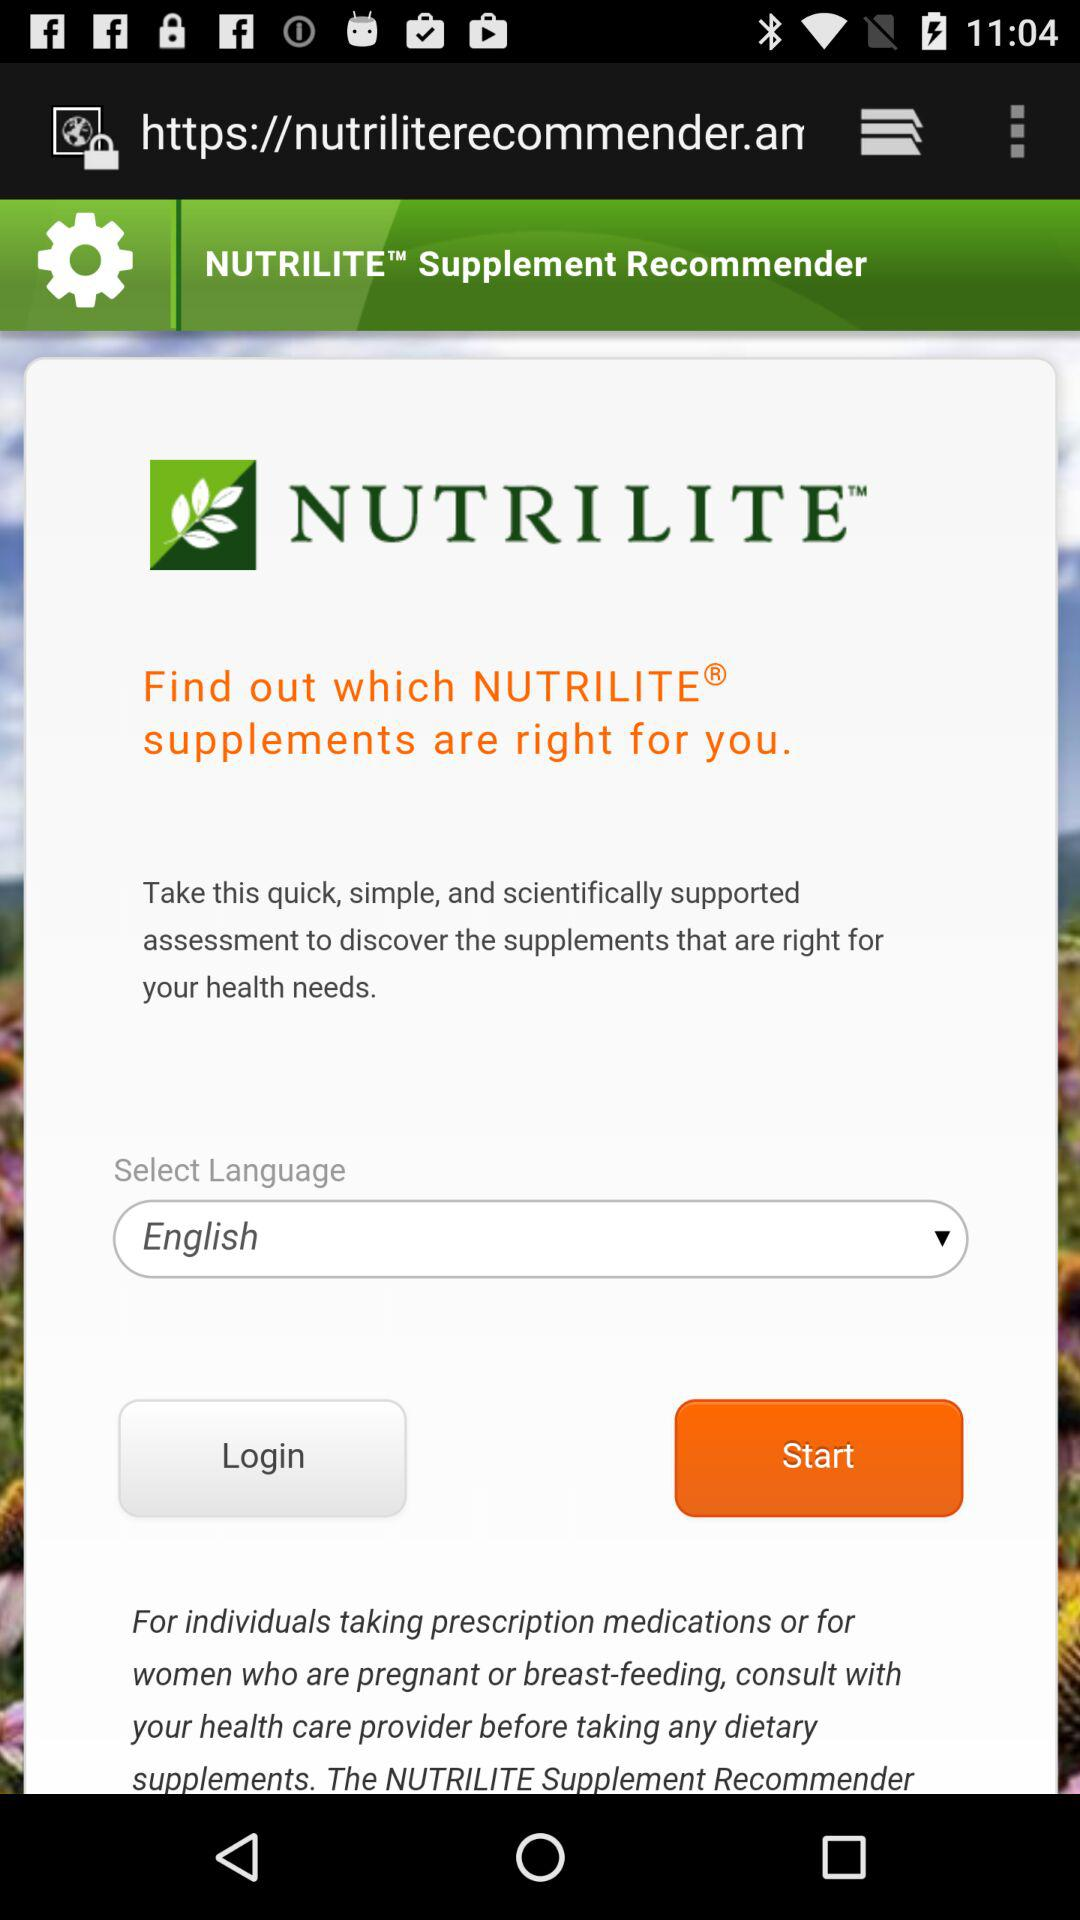What is the app title? The app title is "NUTRILITE". 